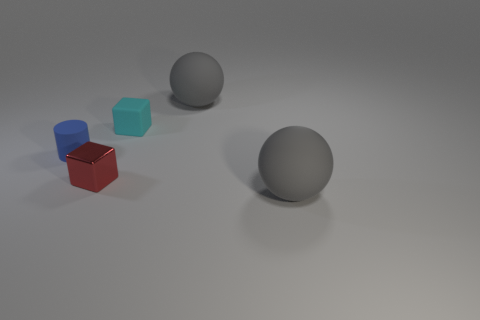What color is the large matte object that is behind the large rubber thing to the right of the large sphere behind the red block?
Keep it short and to the point. Gray. What is the color of the other small matte object that is the same shape as the red thing?
Your answer should be very brief. Cyan. Are there the same number of cyan matte cubes that are left of the tiny cyan matte object and tiny cubes?
Provide a short and direct response. No. How many blocks are either metallic things or big gray objects?
Offer a very short reply. 1. The other tiny thing that is the same material as the small cyan object is what color?
Ensure brevity in your answer.  Blue. Is the material of the red object the same as the ball that is in front of the small blue rubber cylinder?
Keep it short and to the point. No. How many things are gray spheres or tiny matte cylinders?
Make the answer very short. 3. Are there any red shiny things that have the same shape as the small blue rubber thing?
Give a very brief answer. No. There is a blue object; what number of small blue cylinders are in front of it?
Provide a short and direct response. 0. There is a gray thing that is behind the gray rubber object that is in front of the tiny blue object; what is its material?
Provide a succinct answer. Rubber. 